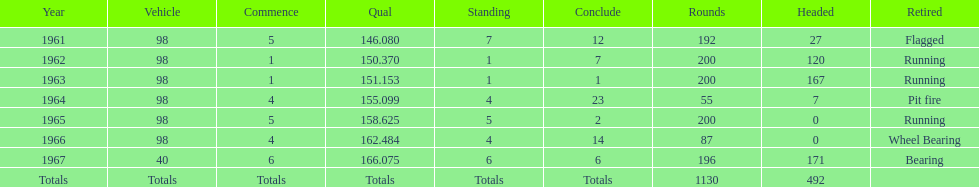How many consecutive years did parnelli place in the top 5? 5. 